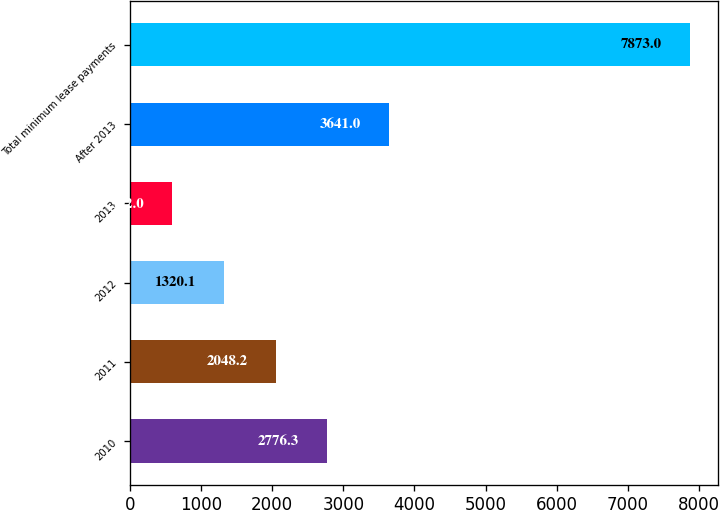<chart> <loc_0><loc_0><loc_500><loc_500><bar_chart><fcel>2010<fcel>2011<fcel>2012<fcel>2013<fcel>After 2013<fcel>Total minimum lease payments<nl><fcel>2776.3<fcel>2048.2<fcel>1320.1<fcel>592<fcel>3641<fcel>7873<nl></chart> 